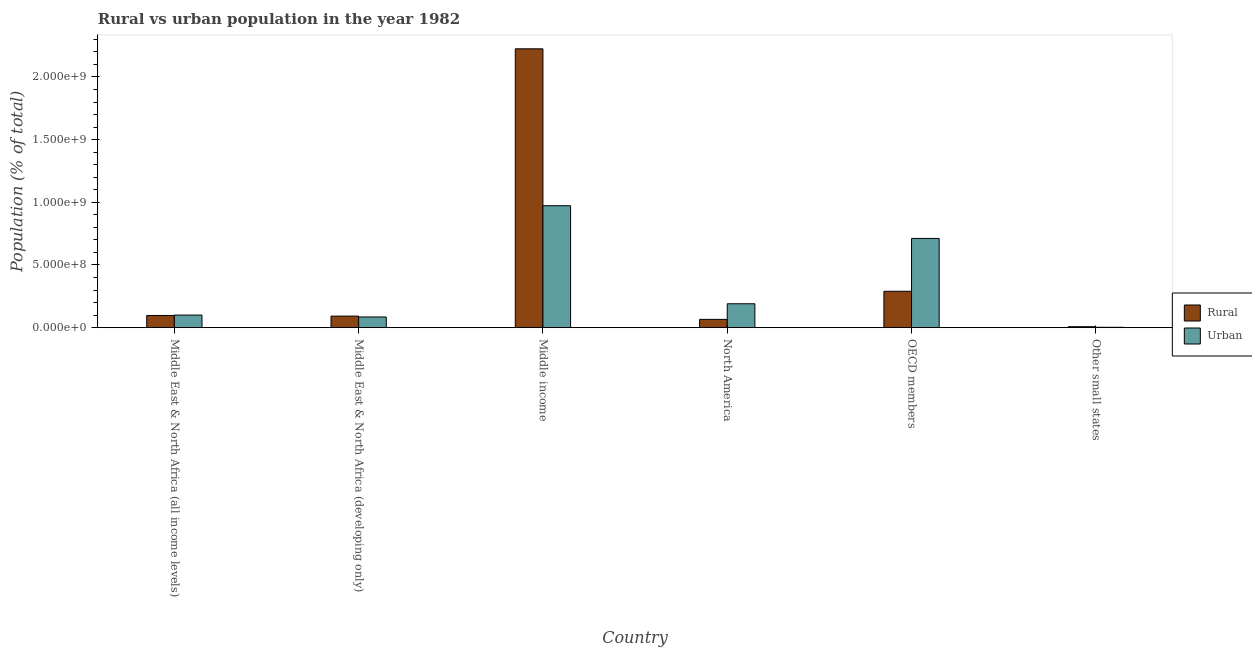How many groups of bars are there?
Offer a terse response. 6. Are the number of bars per tick equal to the number of legend labels?
Provide a short and direct response. Yes. Are the number of bars on each tick of the X-axis equal?
Provide a short and direct response. Yes. How many bars are there on the 6th tick from the left?
Make the answer very short. 2. How many bars are there on the 2nd tick from the right?
Your answer should be very brief. 2. What is the label of the 4th group of bars from the left?
Offer a very short reply. North America. In how many cases, is the number of bars for a given country not equal to the number of legend labels?
Offer a very short reply. 0. What is the rural population density in Other small states?
Your answer should be compact. 7.65e+06. Across all countries, what is the maximum rural population density?
Your response must be concise. 2.22e+09. Across all countries, what is the minimum urban population density?
Your response must be concise. 2.99e+06. In which country was the urban population density minimum?
Offer a very short reply. Other small states. What is the total rural population density in the graph?
Your response must be concise. 2.78e+09. What is the difference between the rural population density in Middle East & North Africa (all income levels) and that in North America?
Ensure brevity in your answer.  3.10e+07. What is the difference between the rural population density in OECD members and the urban population density in Middle East & North Africa (all income levels)?
Make the answer very short. 1.90e+08. What is the average rural population density per country?
Make the answer very short. 4.63e+08. What is the difference between the rural population density and urban population density in Middle East & North Africa (all income levels)?
Your response must be concise. -3.27e+06. In how many countries, is the urban population density greater than 300000000 %?
Provide a short and direct response. 2. What is the ratio of the rural population density in Middle East & North Africa (all income levels) to that in Other small states?
Offer a very short reply. 12.71. Is the urban population density in Middle East & North Africa (all income levels) less than that in OECD members?
Offer a terse response. Yes. What is the difference between the highest and the second highest rural population density?
Provide a succinct answer. 1.93e+09. What is the difference between the highest and the lowest urban population density?
Provide a succinct answer. 9.70e+08. What does the 1st bar from the left in North America represents?
Your response must be concise. Rural. What does the 2nd bar from the right in Middle income represents?
Provide a succinct answer. Rural. How many countries are there in the graph?
Offer a terse response. 6. Are the values on the major ticks of Y-axis written in scientific E-notation?
Keep it short and to the point. Yes. Where does the legend appear in the graph?
Give a very brief answer. Center right. How many legend labels are there?
Give a very brief answer. 2. How are the legend labels stacked?
Provide a succinct answer. Vertical. What is the title of the graph?
Make the answer very short. Rural vs urban population in the year 1982. What is the label or title of the X-axis?
Provide a short and direct response. Country. What is the label or title of the Y-axis?
Give a very brief answer. Population (% of total). What is the Population (% of total) in Rural in Middle East & North Africa (all income levels)?
Your answer should be very brief. 9.72e+07. What is the Population (% of total) of Urban in Middle East & North Africa (all income levels)?
Give a very brief answer. 1.00e+08. What is the Population (% of total) in Rural in Middle East & North Africa (developing only)?
Your response must be concise. 9.22e+07. What is the Population (% of total) of Urban in Middle East & North Africa (developing only)?
Your answer should be compact. 8.52e+07. What is the Population (% of total) in Rural in Middle income?
Your answer should be very brief. 2.22e+09. What is the Population (% of total) of Urban in Middle income?
Offer a very short reply. 9.73e+08. What is the Population (% of total) of Rural in North America?
Keep it short and to the point. 6.62e+07. What is the Population (% of total) in Urban in North America?
Keep it short and to the point. 1.91e+08. What is the Population (% of total) of Rural in OECD members?
Make the answer very short. 2.90e+08. What is the Population (% of total) in Urban in OECD members?
Give a very brief answer. 7.12e+08. What is the Population (% of total) of Rural in Other small states?
Your answer should be very brief. 7.65e+06. What is the Population (% of total) in Urban in Other small states?
Provide a succinct answer. 2.99e+06. Across all countries, what is the maximum Population (% of total) of Rural?
Your answer should be very brief. 2.22e+09. Across all countries, what is the maximum Population (% of total) of Urban?
Keep it short and to the point. 9.73e+08. Across all countries, what is the minimum Population (% of total) in Rural?
Ensure brevity in your answer.  7.65e+06. Across all countries, what is the minimum Population (% of total) of Urban?
Offer a terse response. 2.99e+06. What is the total Population (% of total) in Rural in the graph?
Offer a very short reply. 2.78e+09. What is the total Population (% of total) of Urban in the graph?
Your response must be concise. 2.06e+09. What is the difference between the Population (% of total) of Rural in Middle East & North Africa (all income levels) and that in Middle East & North Africa (developing only)?
Provide a succinct answer. 4.98e+06. What is the difference between the Population (% of total) in Urban in Middle East & North Africa (all income levels) and that in Middle East & North Africa (developing only)?
Ensure brevity in your answer.  1.53e+07. What is the difference between the Population (% of total) of Rural in Middle East & North Africa (all income levels) and that in Middle income?
Provide a short and direct response. -2.13e+09. What is the difference between the Population (% of total) in Urban in Middle East & North Africa (all income levels) and that in Middle income?
Provide a short and direct response. -8.72e+08. What is the difference between the Population (% of total) in Rural in Middle East & North Africa (all income levels) and that in North America?
Provide a short and direct response. 3.10e+07. What is the difference between the Population (% of total) in Urban in Middle East & North Africa (all income levels) and that in North America?
Offer a very short reply. -9.02e+07. What is the difference between the Population (% of total) of Rural in Middle East & North Africa (all income levels) and that in OECD members?
Keep it short and to the point. -1.93e+08. What is the difference between the Population (% of total) of Urban in Middle East & North Africa (all income levels) and that in OECD members?
Ensure brevity in your answer.  -6.11e+08. What is the difference between the Population (% of total) of Rural in Middle East & North Africa (all income levels) and that in Other small states?
Your response must be concise. 8.95e+07. What is the difference between the Population (% of total) of Urban in Middle East & North Africa (all income levels) and that in Other small states?
Offer a very short reply. 9.75e+07. What is the difference between the Population (% of total) of Rural in Middle East & North Africa (developing only) and that in Middle income?
Your response must be concise. -2.13e+09. What is the difference between the Population (% of total) of Urban in Middle East & North Africa (developing only) and that in Middle income?
Keep it short and to the point. -8.87e+08. What is the difference between the Population (% of total) of Rural in Middle East & North Africa (developing only) and that in North America?
Provide a short and direct response. 2.60e+07. What is the difference between the Population (% of total) in Urban in Middle East & North Africa (developing only) and that in North America?
Your answer should be very brief. -1.06e+08. What is the difference between the Population (% of total) of Rural in Middle East & North Africa (developing only) and that in OECD members?
Offer a very short reply. -1.98e+08. What is the difference between the Population (% of total) in Urban in Middle East & North Africa (developing only) and that in OECD members?
Your answer should be compact. -6.27e+08. What is the difference between the Population (% of total) in Rural in Middle East & North Africa (developing only) and that in Other small states?
Make the answer very short. 8.46e+07. What is the difference between the Population (% of total) of Urban in Middle East & North Africa (developing only) and that in Other small states?
Provide a short and direct response. 8.22e+07. What is the difference between the Population (% of total) in Rural in Middle income and that in North America?
Provide a short and direct response. 2.16e+09. What is the difference between the Population (% of total) in Urban in Middle income and that in North America?
Give a very brief answer. 7.82e+08. What is the difference between the Population (% of total) in Rural in Middle income and that in OECD members?
Offer a very short reply. 1.93e+09. What is the difference between the Population (% of total) of Urban in Middle income and that in OECD members?
Your answer should be compact. 2.61e+08. What is the difference between the Population (% of total) in Rural in Middle income and that in Other small states?
Give a very brief answer. 2.22e+09. What is the difference between the Population (% of total) in Urban in Middle income and that in Other small states?
Give a very brief answer. 9.70e+08. What is the difference between the Population (% of total) in Rural in North America and that in OECD members?
Make the answer very short. -2.24e+08. What is the difference between the Population (% of total) of Urban in North America and that in OECD members?
Keep it short and to the point. -5.21e+08. What is the difference between the Population (% of total) of Rural in North America and that in Other small states?
Ensure brevity in your answer.  5.86e+07. What is the difference between the Population (% of total) of Urban in North America and that in Other small states?
Offer a very short reply. 1.88e+08. What is the difference between the Population (% of total) of Rural in OECD members and that in Other small states?
Provide a succinct answer. 2.83e+08. What is the difference between the Population (% of total) in Urban in OECD members and that in Other small states?
Give a very brief answer. 7.09e+08. What is the difference between the Population (% of total) of Rural in Middle East & North Africa (all income levels) and the Population (% of total) of Urban in Middle East & North Africa (developing only)?
Ensure brevity in your answer.  1.20e+07. What is the difference between the Population (% of total) in Rural in Middle East & North Africa (all income levels) and the Population (% of total) in Urban in Middle income?
Offer a very short reply. -8.75e+08. What is the difference between the Population (% of total) in Rural in Middle East & North Africa (all income levels) and the Population (% of total) in Urban in North America?
Make the answer very short. -9.35e+07. What is the difference between the Population (% of total) of Rural in Middle East & North Africa (all income levels) and the Population (% of total) of Urban in OECD members?
Provide a succinct answer. -6.15e+08. What is the difference between the Population (% of total) of Rural in Middle East & North Africa (all income levels) and the Population (% of total) of Urban in Other small states?
Offer a very short reply. 9.42e+07. What is the difference between the Population (% of total) in Rural in Middle East & North Africa (developing only) and the Population (% of total) in Urban in Middle income?
Offer a terse response. -8.80e+08. What is the difference between the Population (% of total) of Rural in Middle East & North Africa (developing only) and the Population (% of total) of Urban in North America?
Make the answer very short. -9.85e+07. What is the difference between the Population (% of total) in Rural in Middle East & North Africa (developing only) and the Population (% of total) in Urban in OECD members?
Keep it short and to the point. -6.20e+08. What is the difference between the Population (% of total) in Rural in Middle East & North Africa (developing only) and the Population (% of total) in Urban in Other small states?
Keep it short and to the point. 8.92e+07. What is the difference between the Population (% of total) of Rural in Middle income and the Population (% of total) of Urban in North America?
Provide a short and direct response. 2.03e+09. What is the difference between the Population (% of total) of Rural in Middle income and the Population (% of total) of Urban in OECD members?
Provide a succinct answer. 1.51e+09. What is the difference between the Population (% of total) in Rural in Middle income and the Population (% of total) in Urban in Other small states?
Provide a short and direct response. 2.22e+09. What is the difference between the Population (% of total) of Rural in North America and the Population (% of total) of Urban in OECD members?
Keep it short and to the point. -6.46e+08. What is the difference between the Population (% of total) of Rural in North America and the Population (% of total) of Urban in Other small states?
Provide a succinct answer. 6.32e+07. What is the difference between the Population (% of total) of Rural in OECD members and the Population (% of total) of Urban in Other small states?
Your answer should be very brief. 2.87e+08. What is the average Population (% of total) in Rural per country?
Ensure brevity in your answer.  4.63e+08. What is the average Population (% of total) of Urban per country?
Offer a terse response. 3.44e+08. What is the difference between the Population (% of total) of Rural and Population (% of total) of Urban in Middle East & North Africa (all income levels)?
Give a very brief answer. -3.27e+06. What is the difference between the Population (% of total) in Rural and Population (% of total) in Urban in Middle East & North Africa (developing only)?
Ensure brevity in your answer.  7.01e+06. What is the difference between the Population (% of total) in Rural and Population (% of total) in Urban in Middle income?
Offer a terse response. 1.25e+09. What is the difference between the Population (% of total) of Rural and Population (% of total) of Urban in North America?
Make the answer very short. -1.24e+08. What is the difference between the Population (% of total) of Rural and Population (% of total) of Urban in OECD members?
Provide a short and direct response. -4.21e+08. What is the difference between the Population (% of total) of Rural and Population (% of total) of Urban in Other small states?
Give a very brief answer. 4.66e+06. What is the ratio of the Population (% of total) in Rural in Middle East & North Africa (all income levels) to that in Middle East & North Africa (developing only)?
Your response must be concise. 1.05. What is the ratio of the Population (% of total) in Urban in Middle East & North Africa (all income levels) to that in Middle East & North Africa (developing only)?
Make the answer very short. 1.18. What is the ratio of the Population (% of total) in Rural in Middle East & North Africa (all income levels) to that in Middle income?
Your response must be concise. 0.04. What is the ratio of the Population (% of total) of Urban in Middle East & North Africa (all income levels) to that in Middle income?
Keep it short and to the point. 0.1. What is the ratio of the Population (% of total) of Rural in Middle East & North Africa (all income levels) to that in North America?
Offer a terse response. 1.47. What is the ratio of the Population (% of total) in Urban in Middle East & North Africa (all income levels) to that in North America?
Your response must be concise. 0.53. What is the ratio of the Population (% of total) in Rural in Middle East & North Africa (all income levels) to that in OECD members?
Offer a very short reply. 0.33. What is the ratio of the Population (% of total) in Urban in Middle East & North Africa (all income levels) to that in OECD members?
Your answer should be very brief. 0.14. What is the ratio of the Population (% of total) of Rural in Middle East & North Africa (all income levels) to that in Other small states?
Provide a succinct answer. 12.71. What is the ratio of the Population (% of total) in Urban in Middle East & North Africa (all income levels) to that in Other small states?
Your response must be concise. 33.61. What is the ratio of the Population (% of total) of Rural in Middle East & North Africa (developing only) to that in Middle income?
Offer a terse response. 0.04. What is the ratio of the Population (% of total) of Urban in Middle East & North Africa (developing only) to that in Middle income?
Your response must be concise. 0.09. What is the ratio of the Population (% of total) in Rural in Middle East & North Africa (developing only) to that in North America?
Your answer should be very brief. 1.39. What is the ratio of the Population (% of total) in Urban in Middle East & North Africa (developing only) to that in North America?
Make the answer very short. 0.45. What is the ratio of the Population (% of total) in Rural in Middle East & North Africa (developing only) to that in OECD members?
Ensure brevity in your answer.  0.32. What is the ratio of the Population (% of total) in Urban in Middle East & North Africa (developing only) to that in OECD members?
Provide a succinct answer. 0.12. What is the ratio of the Population (% of total) in Rural in Middle East & North Africa (developing only) to that in Other small states?
Your answer should be very brief. 12.06. What is the ratio of the Population (% of total) of Urban in Middle East & North Africa (developing only) to that in Other small states?
Make the answer very short. 28.5. What is the ratio of the Population (% of total) in Rural in Middle income to that in North America?
Give a very brief answer. 33.59. What is the ratio of the Population (% of total) of Urban in Middle income to that in North America?
Keep it short and to the point. 5.1. What is the ratio of the Population (% of total) in Rural in Middle income to that in OECD members?
Provide a short and direct response. 7.66. What is the ratio of the Population (% of total) in Urban in Middle income to that in OECD members?
Provide a succinct answer. 1.37. What is the ratio of the Population (% of total) of Rural in Middle income to that in Other small states?
Make the answer very short. 290.92. What is the ratio of the Population (% of total) of Urban in Middle income to that in Other small states?
Make the answer very short. 325.36. What is the ratio of the Population (% of total) in Rural in North America to that in OECD members?
Offer a terse response. 0.23. What is the ratio of the Population (% of total) in Urban in North America to that in OECD members?
Offer a terse response. 0.27. What is the ratio of the Population (% of total) of Rural in North America to that in Other small states?
Your answer should be compact. 8.66. What is the ratio of the Population (% of total) in Urban in North America to that in Other small states?
Provide a succinct answer. 63.79. What is the ratio of the Population (% of total) in Rural in OECD members to that in Other small states?
Your answer should be very brief. 37.97. What is the ratio of the Population (% of total) of Urban in OECD members to that in Other small states?
Your answer should be compact. 238.09. What is the difference between the highest and the second highest Population (% of total) in Rural?
Provide a succinct answer. 1.93e+09. What is the difference between the highest and the second highest Population (% of total) in Urban?
Make the answer very short. 2.61e+08. What is the difference between the highest and the lowest Population (% of total) in Rural?
Offer a very short reply. 2.22e+09. What is the difference between the highest and the lowest Population (% of total) in Urban?
Offer a very short reply. 9.70e+08. 